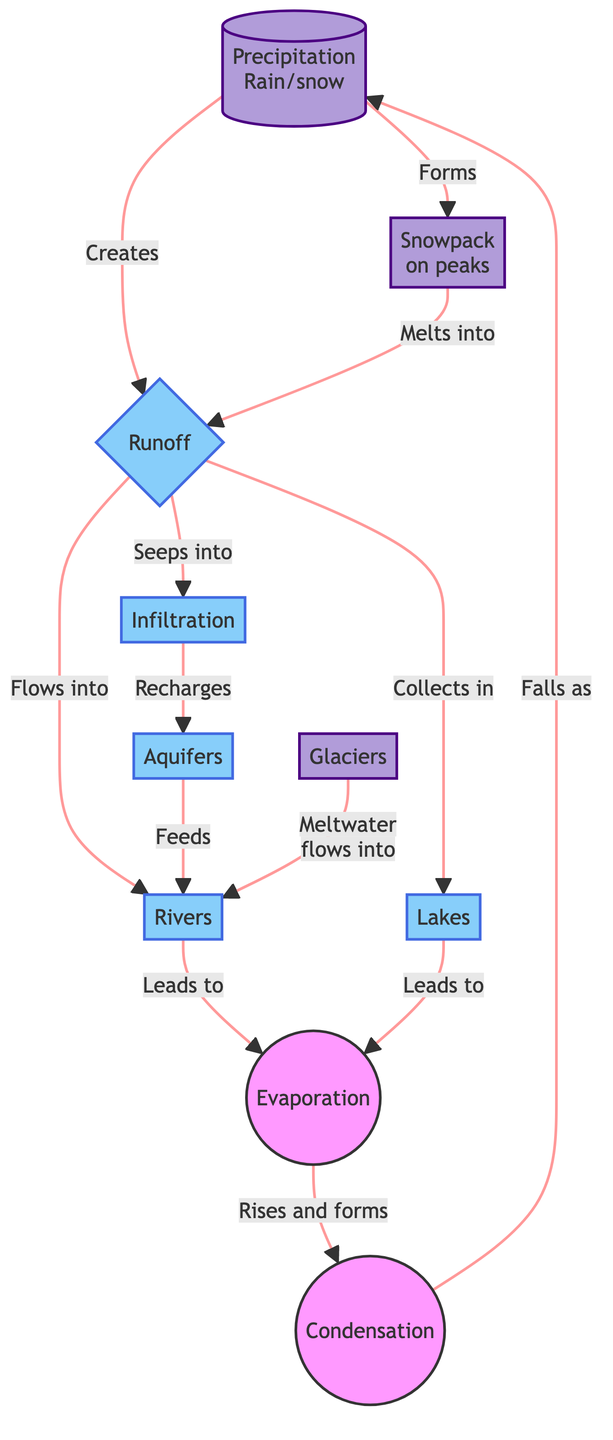What are the two types of precipitation illustrated in the diagram? The diagram mentions "Rain" and "Snow" as the forms of precipitation that occur in mountain regions, indicating the various ways moisture can fall from the atmosphere.
Answer: Rain and Snow How does runoff relate to rivers? The diagram shows that runoff flows into rivers, indicating a direct connection that situates rivers as a destination for excess water that moves across the surface of the land.
Answer: Flows into What processes follow after evaporation? The diagram illustrates that after evaporation occurs, the water vapor rises and condenses to fall back as precipitation. Therefore, condensation is the immediate result following evaporation.
Answer: Condensation What does groundwater from infiltration recharge? The diagram explicitly states that infiltration recharges aquifers, suggesting that the water that seeps into the ground supplies the underground water reservoirs.
Answer: Aquifers How many main geological features are depicted in the diagram? The diagram lists "Rivers," "Glaciers," "Lakes," and "Aquifers" as the main geological features involved in the water cycle in mountain regions, making a total of four distinct features highlighted.
Answer: Four 